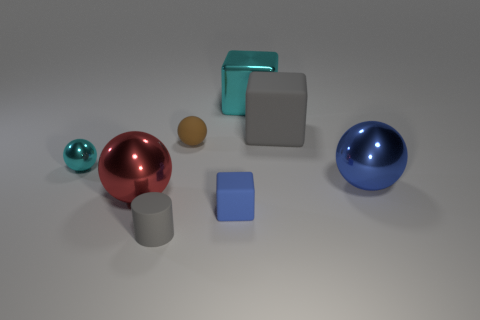Add 2 tiny cyan metallic objects. How many objects exist? 10 Subtract all cylinders. How many objects are left? 7 Subtract 1 blue cubes. How many objects are left? 7 Subtract all small purple rubber spheres. Subtract all large red balls. How many objects are left? 7 Add 1 blue matte cubes. How many blue matte cubes are left? 2 Add 3 brown rubber blocks. How many brown rubber blocks exist? 3 